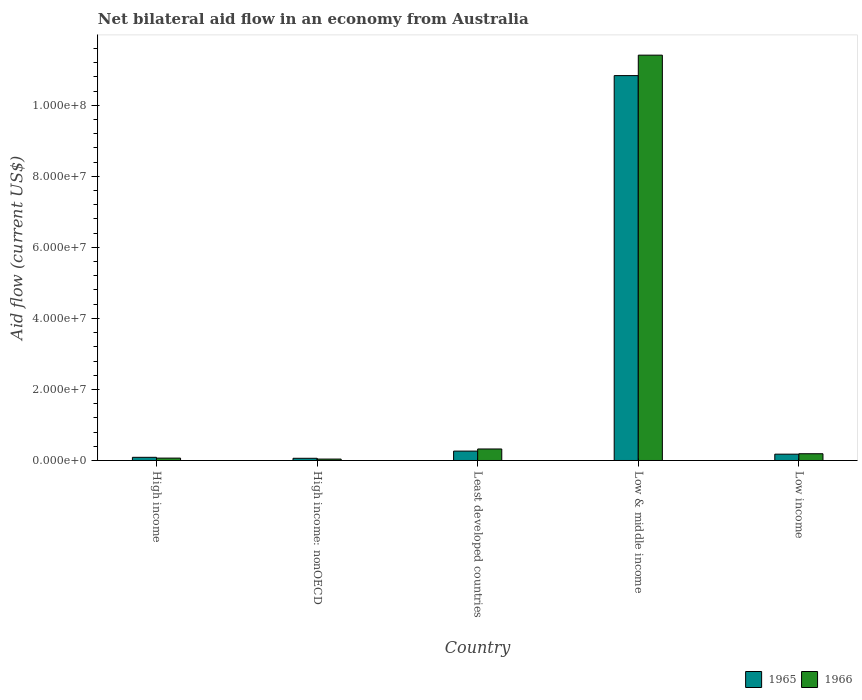Are the number of bars per tick equal to the number of legend labels?
Provide a short and direct response. Yes. How many bars are there on the 2nd tick from the right?
Your response must be concise. 2. What is the label of the 3rd group of bars from the left?
Provide a succinct answer. Least developed countries. What is the net bilateral aid flow in 1966 in Least developed countries?
Offer a terse response. 3.24e+06. Across all countries, what is the maximum net bilateral aid flow in 1966?
Give a very brief answer. 1.14e+08. Across all countries, what is the minimum net bilateral aid flow in 1966?
Provide a succinct answer. 4.00e+05. In which country was the net bilateral aid flow in 1965 minimum?
Provide a succinct answer. High income: nonOECD. What is the total net bilateral aid flow in 1966 in the graph?
Offer a very short reply. 1.20e+08. What is the difference between the net bilateral aid flow in 1965 in High income and that in Low income?
Your answer should be very brief. -8.90e+05. What is the difference between the net bilateral aid flow in 1966 in Least developed countries and the net bilateral aid flow in 1965 in High income: nonOECD?
Make the answer very short. 2.62e+06. What is the average net bilateral aid flow in 1965 per country?
Make the answer very short. 2.29e+07. What is the difference between the net bilateral aid flow of/in 1965 and net bilateral aid flow of/in 1966 in Low income?
Make the answer very short. -1.20e+05. In how many countries, is the net bilateral aid flow in 1965 greater than 28000000 US$?
Provide a succinct answer. 1. What is the ratio of the net bilateral aid flow in 1965 in Least developed countries to that in Low income?
Your answer should be compact. 1.48. Is the difference between the net bilateral aid flow in 1965 in High income: nonOECD and Least developed countries greater than the difference between the net bilateral aid flow in 1966 in High income: nonOECD and Least developed countries?
Your answer should be very brief. Yes. What is the difference between the highest and the second highest net bilateral aid flow in 1965?
Keep it short and to the point. 1.07e+08. What is the difference between the highest and the lowest net bilateral aid flow in 1966?
Ensure brevity in your answer.  1.14e+08. In how many countries, is the net bilateral aid flow in 1965 greater than the average net bilateral aid flow in 1965 taken over all countries?
Your answer should be compact. 1. Is the sum of the net bilateral aid flow in 1966 in High income and Low income greater than the maximum net bilateral aid flow in 1965 across all countries?
Your answer should be compact. No. What does the 2nd bar from the left in Low & middle income represents?
Your answer should be compact. 1966. What does the 2nd bar from the right in High income represents?
Ensure brevity in your answer.  1965. Are the values on the major ticks of Y-axis written in scientific E-notation?
Your answer should be compact. Yes. Does the graph contain grids?
Make the answer very short. No. How many legend labels are there?
Ensure brevity in your answer.  2. What is the title of the graph?
Give a very brief answer. Net bilateral aid flow in an economy from Australia. Does "1976" appear as one of the legend labels in the graph?
Ensure brevity in your answer.  No. What is the label or title of the X-axis?
Provide a succinct answer. Country. What is the Aid flow (current US$) in 1965 in High income?
Make the answer very short. 8.90e+05. What is the Aid flow (current US$) of 1966 in High income?
Make the answer very short. 6.70e+05. What is the Aid flow (current US$) in 1965 in High income: nonOECD?
Offer a terse response. 6.20e+05. What is the Aid flow (current US$) of 1966 in High income: nonOECD?
Provide a succinct answer. 4.00e+05. What is the Aid flow (current US$) in 1965 in Least developed countries?
Offer a terse response. 2.64e+06. What is the Aid flow (current US$) in 1966 in Least developed countries?
Provide a short and direct response. 3.24e+06. What is the Aid flow (current US$) of 1965 in Low & middle income?
Provide a succinct answer. 1.08e+08. What is the Aid flow (current US$) of 1966 in Low & middle income?
Ensure brevity in your answer.  1.14e+08. What is the Aid flow (current US$) of 1965 in Low income?
Make the answer very short. 1.78e+06. What is the Aid flow (current US$) in 1966 in Low income?
Keep it short and to the point. 1.90e+06. Across all countries, what is the maximum Aid flow (current US$) in 1965?
Provide a short and direct response. 1.08e+08. Across all countries, what is the maximum Aid flow (current US$) in 1966?
Make the answer very short. 1.14e+08. Across all countries, what is the minimum Aid flow (current US$) of 1965?
Keep it short and to the point. 6.20e+05. What is the total Aid flow (current US$) in 1965 in the graph?
Ensure brevity in your answer.  1.14e+08. What is the total Aid flow (current US$) in 1966 in the graph?
Give a very brief answer. 1.20e+08. What is the difference between the Aid flow (current US$) in 1965 in High income and that in Least developed countries?
Provide a short and direct response. -1.75e+06. What is the difference between the Aid flow (current US$) in 1966 in High income and that in Least developed countries?
Provide a short and direct response. -2.57e+06. What is the difference between the Aid flow (current US$) in 1965 in High income and that in Low & middle income?
Provide a short and direct response. -1.07e+08. What is the difference between the Aid flow (current US$) in 1966 in High income and that in Low & middle income?
Your answer should be compact. -1.13e+08. What is the difference between the Aid flow (current US$) in 1965 in High income and that in Low income?
Give a very brief answer. -8.90e+05. What is the difference between the Aid flow (current US$) of 1966 in High income and that in Low income?
Give a very brief answer. -1.23e+06. What is the difference between the Aid flow (current US$) in 1965 in High income: nonOECD and that in Least developed countries?
Provide a short and direct response. -2.02e+06. What is the difference between the Aid flow (current US$) of 1966 in High income: nonOECD and that in Least developed countries?
Provide a succinct answer. -2.84e+06. What is the difference between the Aid flow (current US$) in 1965 in High income: nonOECD and that in Low & middle income?
Your response must be concise. -1.08e+08. What is the difference between the Aid flow (current US$) of 1966 in High income: nonOECD and that in Low & middle income?
Provide a succinct answer. -1.14e+08. What is the difference between the Aid flow (current US$) in 1965 in High income: nonOECD and that in Low income?
Offer a very short reply. -1.16e+06. What is the difference between the Aid flow (current US$) in 1966 in High income: nonOECD and that in Low income?
Give a very brief answer. -1.50e+06. What is the difference between the Aid flow (current US$) of 1965 in Least developed countries and that in Low & middle income?
Provide a short and direct response. -1.06e+08. What is the difference between the Aid flow (current US$) of 1966 in Least developed countries and that in Low & middle income?
Offer a terse response. -1.11e+08. What is the difference between the Aid flow (current US$) of 1965 in Least developed countries and that in Low income?
Offer a terse response. 8.60e+05. What is the difference between the Aid flow (current US$) of 1966 in Least developed countries and that in Low income?
Ensure brevity in your answer.  1.34e+06. What is the difference between the Aid flow (current US$) of 1965 in Low & middle income and that in Low income?
Give a very brief answer. 1.07e+08. What is the difference between the Aid flow (current US$) of 1966 in Low & middle income and that in Low income?
Provide a short and direct response. 1.12e+08. What is the difference between the Aid flow (current US$) of 1965 in High income and the Aid flow (current US$) of 1966 in Least developed countries?
Keep it short and to the point. -2.35e+06. What is the difference between the Aid flow (current US$) of 1965 in High income and the Aid flow (current US$) of 1966 in Low & middle income?
Your answer should be very brief. -1.13e+08. What is the difference between the Aid flow (current US$) of 1965 in High income and the Aid flow (current US$) of 1966 in Low income?
Offer a terse response. -1.01e+06. What is the difference between the Aid flow (current US$) in 1965 in High income: nonOECD and the Aid flow (current US$) in 1966 in Least developed countries?
Give a very brief answer. -2.62e+06. What is the difference between the Aid flow (current US$) in 1965 in High income: nonOECD and the Aid flow (current US$) in 1966 in Low & middle income?
Make the answer very short. -1.14e+08. What is the difference between the Aid flow (current US$) in 1965 in High income: nonOECD and the Aid flow (current US$) in 1966 in Low income?
Give a very brief answer. -1.28e+06. What is the difference between the Aid flow (current US$) of 1965 in Least developed countries and the Aid flow (current US$) of 1966 in Low & middle income?
Make the answer very short. -1.11e+08. What is the difference between the Aid flow (current US$) in 1965 in Least developed countries and the Aid flow (current US$) in 1966 in Low income?
Offer a terse response. 7.40e+05. What is the difference between the Aid flow (current US$) of 1965 in Low & middle income and the Aid flow (current US$) of 1966 in Low income?
Provide a succinct answer. 1.06e+08. What is the average Aid flow (current US$) of 1965 per country?
Keep it short and to the point. 2.29e+07. What is the average Aid flow (current US$) of 1966 per country?
Make the answer very short. 2.41e+07. What is the difference between the Aid flow (current US$) in 1965 and Aid flow (current US$) in 1966 in High income?
Ensure brevity in your answer.  2.20e+05. What is the difference between the Aid flow (current US$) of 1965 and Aid flow (current US$) of 1966 in Least developed countries?
Offer a terse response. -6.00e+05. What is the difference between the Aid flow (current US$) of 1965 and Aid flow (current US$) of 1966 in Low & middle income?
Give a very brief answer. -5.76e+06. What is the ratio of the Aid flow (current US$) of 1965 in High income to that in High income: nonOECD?
Ensure brevity in your answer.  1.44. What is the ratio of the Aid flow (current US$) in 1966 in High income to that in High income: nonOECD?
Keep it short and to the point. 1.68. What is the ratio of the Aid flow (current US$) in 1965 in High income to that in Least developed countries?
Keep it short and to the point. 0.34. What is the ratio of the Aid flow (current US$) in 1966 in High income to that in Least developed countries?
Ensure brevity in your answer.  0.21. What is the ratio of the Aid flow (current US$) of 1965 in High income to that in Low & middle income?
Offer a terse response. 0.01. What is the ratio of the Aid flow (current US$) in 1966 in High income to that in Low & middle income?
Offer a very short reply. 0.01. What is the ratio of the Aid flow (current US$) in 1965 in High income to that in Low income?
Give a very brief answer. 0.5. What is the ratio of the Aid flow (current US$) of 1966 in High income to that in Low income?
Your response must be concise. 0.35. What is the ratio of the Aid flow (current US$) of 1965 in High income: nonOECD to that in Least developed countries?
Your response must be concise. 0.23. What is the ratio of the Aid flow (current US$) in 1966 in High income: nonOECD to that in Least developed countries?
Your answer should be compact. 0.12. What is the ratio of the Aid flow (current US$) of 1965 in High income: nonOECD to that in Low & middle income?
Provide a succinct answer. 0.01. What is the ratio of the Aid flow (current US$) in 1966 in High income: nonOECD to that in Low & middle income?
Ensure brevity in your answer.  0. What is the ratio of the Aid flow (current US$) in 1965 in High income: nonOECD to that in Low income?
Your response must be concise. 0.35. What is the ratio of the Aid flow (current US$) in 1966 in High income: nonOECD to that in Low income?
Provide a succinct answer. 0.21. What is the ratio of the Aid flow (current US$) of 1965 in Least developed countries to that in Low & middle income?
Keep it short and to the point. 0.02. What is the ratio of the Aid flow (current US$) in 1966 in Least developed countries to that in Low & middle income?
Give a very brief answer. 0.03. What is the ratio of the Aid flow (current US$) of 1965 in Least developed countries to that in Low income?
Your answer should be very brief. 1.48. What is the ratio of the Aid flow (current US$) of 1966 in Least developed countries to that in Low income?
Your answer should be compact. 1.71. What is the ratio of the Aid flow (current US$) in 1965 in Low & middle income to that in Low income?
Provide a short and direct response. 60.88. What is the ratio of the Aid flow (current US$) in 1966 in Low & middle income to that in Low income?
Offer a terse response. 60.06. What is the difference between the highest and the second highest Aid flow (current US$) of 1965?
Offer a terse response. 1.06e+08. What is the difference between the highest and the second highest Aid flow (current US$) of 1966?
Ensure brevity in your answer.  1.11e+08. What is the difference between the highest and the lowest Aid flow (current US$) of 1965?
Make the answer very short. 1.08e+08. What is the difference between the highest and the lowest Aid flow (current US$) in 1966?
Your answer should be very brief. 1.14e+08. 